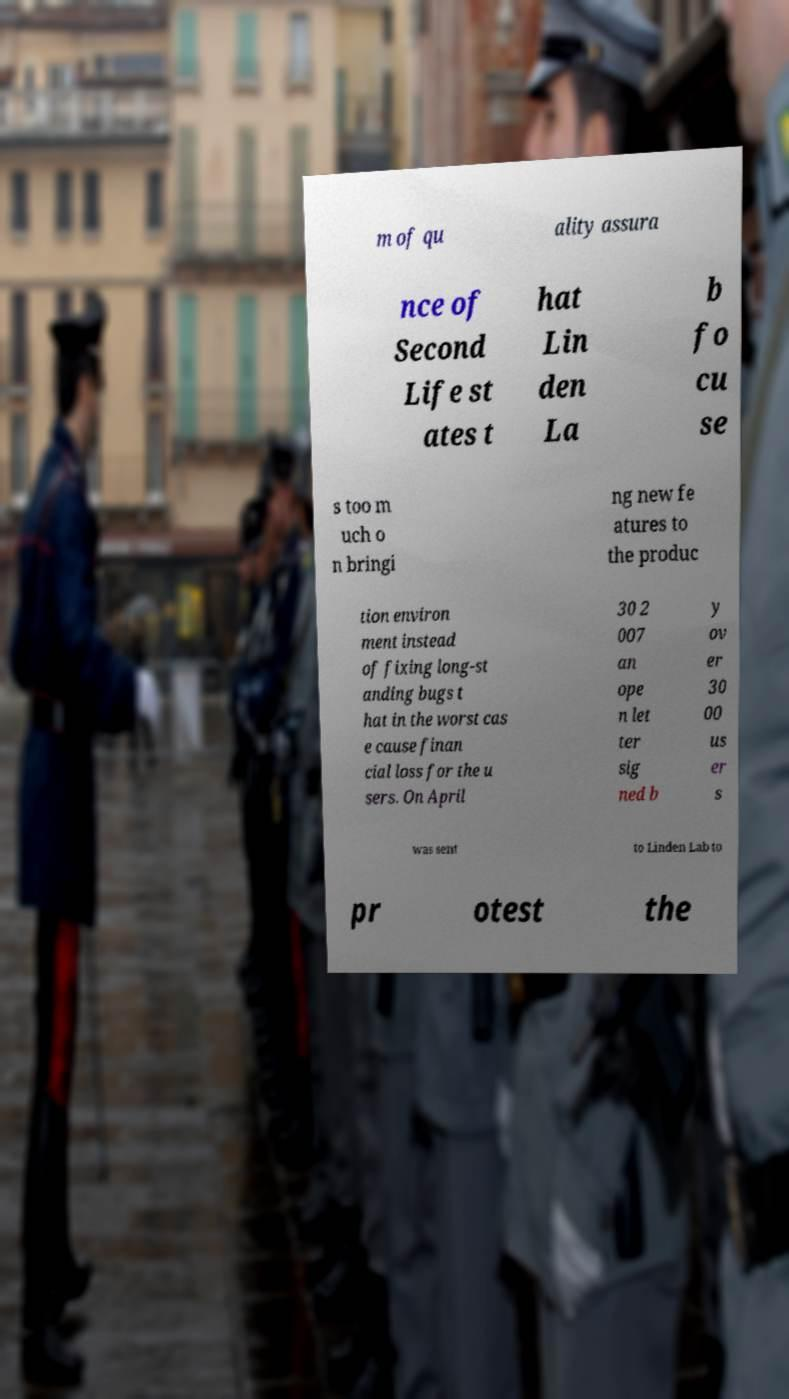For documentation purposes, I need the text within this image transcribed. Could you provide that? m of qu ality assura nce of Second Life st ates t hat Lin den La b fo cu se s too m uch o n bringi ng new fe atures to the produc tion environ ment instead of fixing long-st anding bugs t hat in the worst cas e cause finan cial loss for the u sers. On April 30 2 007 an ope n let ter sig ned b y ov er 30 00 us er s was sent to Linden Lab to pr otest the 